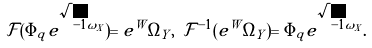<formula> <loc_0><loc_0><loc_500><loc_500>\mathcal { F } ( \Phi _ { q } e ^ { \sqrt { - 1 } \omega _ { X } } ) = e ^ { W } \Omega _ { Y } , \ \mathcal { F } ^ { - 1 } ( e ^ { W } \Omega _ { Y } ) = \Phi _ { q } e ^ { \sqrt { - 1 } \omega _ { X } } .</formula> 